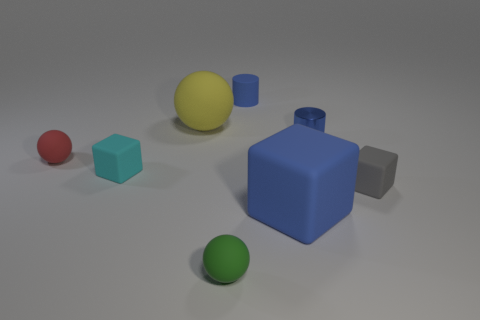Add 1 gray objects. How many objects exist? 9 Subtract all balls. How many objects are left? 5 Add 7 yellow matte cubes. How many yellow matte cubes exist? 7 Subtract 0 gray balls. How many objects are left? 8 Subtract all small green matte objects. Subtract all small cyan things. How many objects are left? 6 Add 5 small cylinders. How many small cylinders are left? 7 